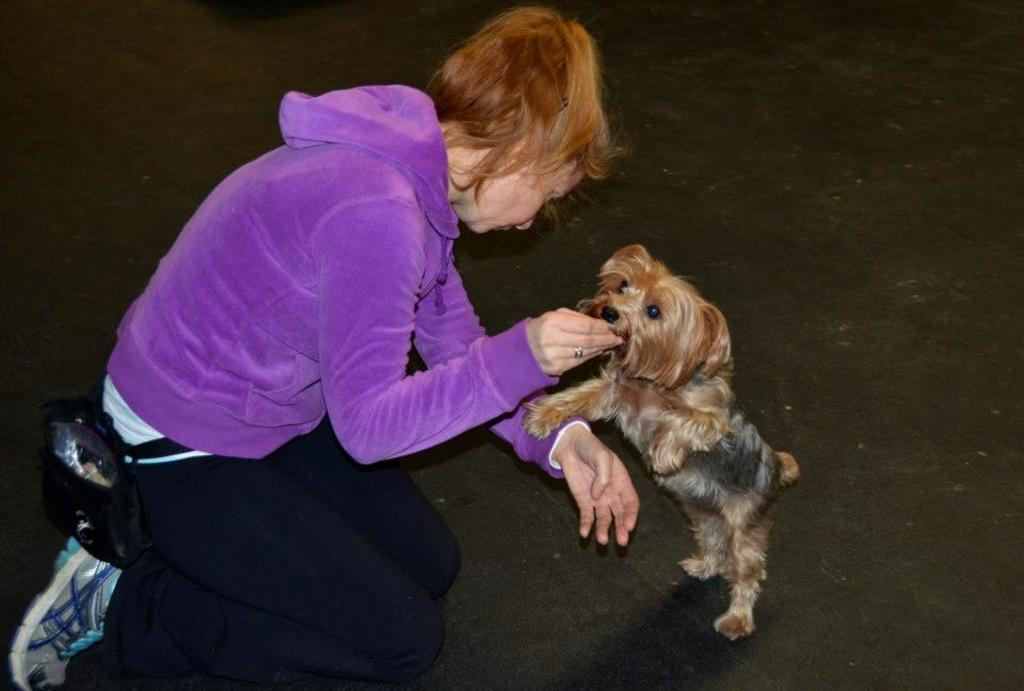Who is present in the image? There is a woman in the image. What other living creature is in the image? There is a dog in the image. What is the woman doing with the dog? The woman is playing with the dog. How many girls are playing with the coal in the image? There are no girls or coal present in the image. What type of ducks can be seen swimming in the background of the image? There are no ducks present in the image. 